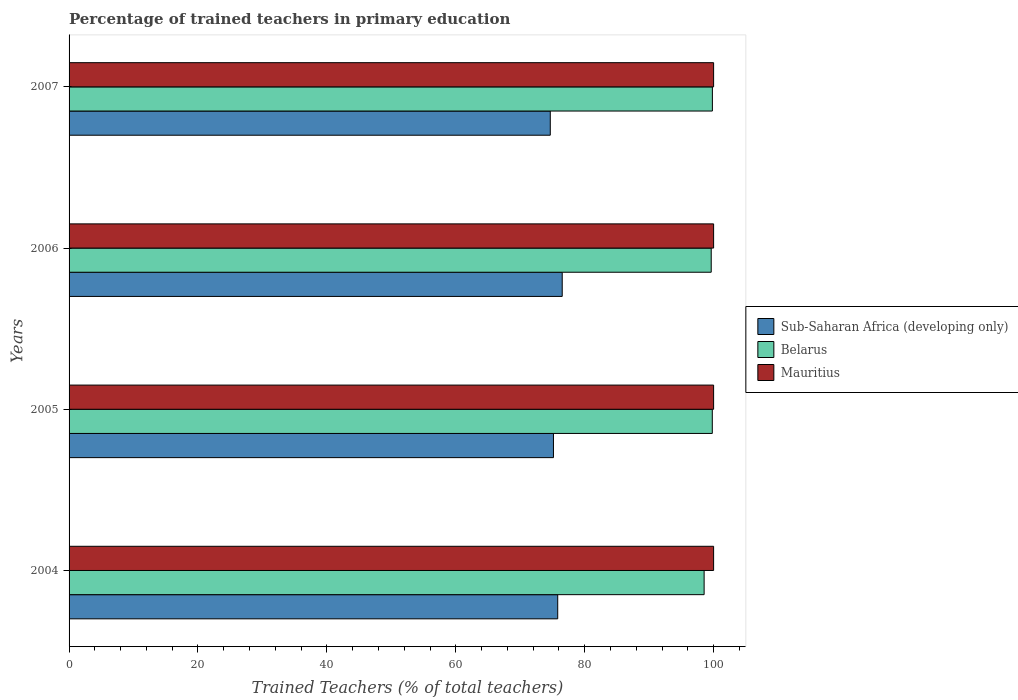How many different coloured bars are there?
Offer a very short reply. 3. How many groups of bars are there?
Your answer should be compact. 4. How many bars are there on the 3rd tick from the bottom?
Offer a terse response. 3. What is the label of the 4th group of bars from the top?
Keep it short and to the point. 2004. In how many cases, is the number of bars for a given year not equal to the number of legend labels?
Your answer should be compact. 0. What is the percentage of trained teachers in Mauritius in 2007?
Your answer should be very brief. 100. Across all years, what is the maximum percentage of trained teachers in Belarus?
Provide a succinct answer. 99.81. Across all years, what is the minimum percentage of trained teachers in Sub-Saharan Africa (developing only)?
Make the answer very short. 74.66. In which year was the percentage of trained teachers in Belarus minimum?
Ensure brevity in your answer.  2004. What is the total percentage of trained teachers in Sub-Saharan Africa (developing only) in the graph?
Your response must be concise. 302.14. What is the difference between the percentage of trained teachers in Mauritius in 2004 and that in 2005?
Provide a short and direct response. 0. What is the difference between the percentage of trained teachers in Mauritius in 2006 and the percentage of trained teachers in Belarus in 2007?
Make the answer very short. 0.19. In the year 2007, what is the difference between the percentage of trained teachers in Belarus and percentage of trained teachers in Sub-Saharan Africa (developing only)?
Offer a terse response. 25.15. In how many years, is the percentage of trained teachers in Belarus greater than 8 %?
Ensure brevity in your answer.  4. Is the difference between the percentage of trained teachers in Belarus in 2004 and 2005 greater than the difference between the percentage of trained teachers in Sub-Saharan Africa (developing only) in 2004 and 2005?
Provide a short and direct response. No. What is the difference between the highest and the second highest percentage of trained teachers in Belarus?
Your response must be concise. 0.01. What is the difference between the highest and the lowest percentage of trained teachers in Belarus?
Your answer should be compact. 1.28. In how many years, is the percentage of trained teachers in Belarus greater than the average percentage of trained teachers in Belarus taken over all years?
Offer a very short reply. 3. What does the 1st bar from the top in 2005 represents?
Ensure brevity in your answer.  Mauritius. What does the 3rd bar from the bottom in 2005 represents?
Make the answer very short. Mauritius. Is it the case that in every year, the sum of the percentage of trained teachers in Belarus and percentage of trained teachers in Mauritius is greater than the percentage of trained teachers in Sub-Saharan Africa (developing only)?
Offer a very short reply. Yes. How many bars are there?
Keep it short and to the point. 12. How many years are there in the graph?
Offer a terse response. 4. What is the difference between two consecutive major ticks on the X-axis?
Your answer should be very brief. 20. Does the graph contain any zero values?
Keep it short and to the point. No. Does the graph contain grids?
Your response must be concise. No. How many legend labels are there?
Ensure brevity in your answer.  3. What is the title of the graph?
Offer a very short reply. Percentage of trained teachers in primary education. Does "Solomon Islands" appear as one of the legend labels in the graph?
Offer a very short reply. No. What is the label or title of the X-axis?
Provide a succinct answer. Trained Teachers (% of total teachers). What is the Trained Teachers (% of total teachers) of Sub-Saharan Africa (developing only) in 2004?
Offer a terse response. 75.81. What is the Trained Teachers (% of total teachers) in Belarus in 2004?
Offer a very short reply. 98.53. What is the Trained Teachers (% of total teachers) of Mauritius in 2004?
Your response must be concise. 100. What is the Trained Teachers (% of total teachers) of Sub-Saharan Africa (developing only) in 2005?
Keep it short and to the point. 75.15. What is the Trained Teachers (% of total teachers) in Belarus in 2005?
Keep it short and to the point. 99.8. What is the Trained Teachers (% of total teachers) in Mauritius in 2005?
Keep it short and to the point. 100. What is the Trained Teachers (% of total teachers) of Sub-Saharan Africa (developing only) in 2006?
Your response must be concise. 76.51. What is the Trained Teachers (% of total teachers) in Belarus in 2006?
Your answer should be very brief. 99.63. What is the Trained Teachers (% of total teachers) of Sub-Saharan Africa (developing only) in 2007?
Provide a short and direct response. 74.66. What is the Trained Teachers (% of total teachers) in Belarus in 2007?
Offer a terse response. 99.81. Across all years, what is the maximum Trained Teachers (% of total teachers) of Sub-Saharan Africa (developing only)?
Ensure brevity in your answer.  76.51. Across all years, what is the maximum Trained Teachers (% of total teachers) of Belarus?
Keep it short and to the point. 99.81. Across all years, what is the minimum Trained Teachers (% of total teachers) in Sub-Saharan Africa (developing only)?
Keep it short and to the point. 74.66. Across all years, what is the minimum Trained Teachers (% of total teachers) of Belarus?
Keep it short and to the point. 98.53. Across all years, what is the minimum Trained Teachers (% of total teachers) in Mauritius?
Make the answer very short. 100. What is the total Trained Teachers (% of total teachers) of Sub-Saharan Africa (developing only) in the graph?
Offer a very short reply. 302.14. What is the total Trained Teachers (% of total teachers) of Belarus in the graph?
Ensure brevity in your answer.  397.76. What is the difference between the Trained Teachers (% of total teachers) of Sub-Saharan Africa (developing only) in 2004 and that in 2005?
Ensure brevity in your answer.  0.66. What is the difference between the Trained Teachers (% of total teachers) in Belarus in 2004 and that in 2005?
Your answer should be very brief. -1.27. What is the difference between the Trained Teachers (% of total teachers) of Sub-Saharan Africa (developing only) in 2004 and that in 2006?
Your answer should be compact. -0.7. What is the difference between the Trained Teachers (% of total teachers) of Belarus in 2004 and that in 2006?
Your answer should be very brief. -1.1. What is the difference between the Trained Teachers (% of total teachers) in Mauritius in 2004 and that in 2006?
Offer a terse response. 0. What is the difference between the Trained Teachers (% of total teachers) of Sub-Saharan Africa (developing only) in 2004 and that in 2007?
Give a very brief answer. 1.15. What is the difference between the Trained Teachers (% of total teachers) in Belarus in 2004 and that in 2007?
Provide a succinct answer. -1.28. What is the difference between the Trained Teachers (% of total teachers) in Sub-Saharan Africa (developing only) in 2005 and that in 2006?
Give a very brief answer. -1.36. What is the difference between the Trained Teachers (% of total teachers) of Belarus in 2005 and that in 2006?
Give a very brief answer. 0.17. What is the difference between the Trained Teachers (% of total teachers) of Mauritius in 2005 and that in 2006?
Provide a succinct answer. 0. What is the difference between the Trained Teachers (% of total teachers) of Sub-Saharan Africa (developing only) in 2005 and that in 2007?
Your answer should be very brief. 0.49. What is the difference between the Trained Teachers (% of total teachers) of Belarus in 2005 and that in 2007?
Provide a succinct answer. -0.01. What is the difference between the Trained Teachers (% of total teachers) of Mauritius in 2005 and that in 2007?
Ensure brevity in your answer.  0. What is the difference between the Trained Teachers (% of total teachers) in Sub-Saharan Africa (developing only) in 2006 and that in 2007?
Your answer should be very brief. 1.85. What is the difference between the Trained Teachers (% of total teachers) in Belarus in 2006 and that in 2007?
Keep it short and to the point. -0.18. What is the difference between the Trained Teachers (% of total teachers) of Sub-Saharan Africa (developing only) in 2004 and the Trained Teachers (% of total teachers) of Belarus in 2005?
Your response must be concise. -23.98. What is the difference between the Trained Teachers (% of total teachers) of Sub-Saharan Africa (developing only) in 2004 and the Trained Teachers (% of total teachers) of Mauritius in 2005?
Keep it short and to the point. -24.19. What is the difference between the Trained Teachers (% of total teachers) of Belarus in 2004 and the Trained Teachers (% of total teachers) of Mauritius in 2005?
Your answer should be very brief. -1.47. What is the difference between the Trained Teachers (% of total teachers) of Sub-Saharan Africa (developing only) in 2004 and the Trained Teachers (% of total teachers) of Belarus in 2006?
Your answer should be very brief. -23.82. What is the difference between the Trained Teachers (% of total teachers) of Sub-Saharan Africa (developing only) in 2004 and the Trained Teachers (% of total teachers) of Mauritius in 2006?
Your response must be concise. -24.19. What is the difference between the Trained Teachers (% of total teachers) in Belarus in 2004 and the Trained Teachers (% of total teachers) in Mauritius in 2006?
Make the answer very short. -1.47. What is the difference between the Trained Teachers (% of total teachers) of Sub-Saharan Africa (developing only) in 2004 and the Trained Teachers (% of total teachers) of Belarus in 2007?
Offer a very short reply. -24. What is the difference between the Trained Teachers (% of total teachers) of Sub-Saharan Africa (developing only) in 2004 and the Trained Teachers (% of total teachers) of Mauritius in 2007?
Make the answer very short. -24.19. What is the difference between the Trained Teachers (% of total teachers) of Belarus in 2004 and the Trained Teachers (% of total teachers) of Mauritius in 2007?
Your answer should be compact. -1.47. What is the difference between the Trained Teachers (% of total teachers) in Sub-Saharan Africa (developing only) in 2005 and the Trained Teachers (% of total teachers) in Belarus in 2006?
Your response must be concise. -24.48. What is the difference between the Trained Teachers (% of total teachers) of Sub-Saharan Africa (developing only) in 2005 and the Trained Teachers (% of total teachers) of Mauritius in 2006?
Keep it short and to the point. -24.85. What is the difference between the Trained Teachers (% of total teachers) of Belarus in 2005 and the Trained Teachers (% of total teachers) of Mauritius in 2006?
Make the answer very short. -0.2. What is the difference between the Trained Teachers (% of total teachers) of Sub-Saharan Africa (developing only) in 2005 and the Trained Teachers (% of total teachers) of Belarus in 2007?
Provide a short and direct response. -24.66. What is the difference between the Trained Teachers (% of total teachers) in Sub-Saharan Africa (developing only) in 2005 and the Trained Teachers (% of total teachers) in Mauritius in 2007?
Ensure brevity in your answer.  -24.85. What is the difference between the Trained Teachers (% of total teachers) of Belarus in 2005 and the Trained Teachers (% of total teachers) of Mauritius in 2007?
Offer a very short reply. -0.2. What is the difference between the Trained Teachers (% of total teachers) of Sub-Saharan Africa (developing only) in 2006 and the Trained Teachers (% of total teachers) of Belarus in 2007?
Offer a very short reply. -23.3. What is the difference between the Trained Teachers (% of total teachers) of Sub-Saharan Africa (developing only) in 2006 and the Trained Teachers (% of total teachers) of Mauritius in 2007?
Your answer should be very brief. -23.49. What is the difference between the Trained Teachers (% of total teachers) in Belarus in 2006 and the Trained Teachers (% of total teachers) in Mauritius in 2007?
Give a very brief answer. -0.37. What is the average Trained Teachers (% of total teachers) of Sub-Saharan Africa (developing only) per year?
Offer a terse response. 75.53. What is the average Trained Teachers (% of total teachers) in Belarus per year?
Your response must be concise. 99.44. In the year 2004, what is the difference between the Trained Teachers (% of total teachers) in Sub-Saharan Africa (developing only) and Trained Teachers (% of total teachers) in Belarus?
Your answer should be very brief. -22.71. In the year 2004, what is the difference between the Trained Teachers (% of total teachers) of Sub-Saharan Africa (developing only) and Trained Teachers (% of total teachers) of Mauritius?
Your answer should be compact. -24.19. In the year 2004, what is the difference between the Trained Teachers (% of total teachers) in Belarus and Trained Teachers (% of total teachers) in Mauritius?
Offer a terse response. -1.47. In the year 2005, what is the difference between the Trained Teachers (% of total teachers) of Sub-Saharan Africa (developing only) and Trained Teachers (% of total teachers) of Belarus?
Keep it short and to the point. -24.65. In the year 2005, what is the difference between the Trained Teachers (% of total teachers) in Sub-Saharan Africa (developing only) and Trained Teachers (% of total teachers) in Mauritius?
Keep it short and to the point. -24.85. In the year 2005, what is the difference between the Trained Teachers (% of total teachers) in Belarus and Trained Teachers (% of total teachers) in Mauritius?
Keep it short and to the point. -0.2. In the year 2006, what is the difference between the Trained Teachers (% of total teachers) of Sub-Saharan Africa (developing only) and Trained Teachers (% of total teachers) of Belarus?
Give a very brief answer. -23.12. In the year 2006, what is the difference between the Trained Teachers (% of total teachers) of Sub-Saharan Africa (developing only) and Trained Teachers (% of total teachers) of Mauritius?
Give a very brief answer. -23.49. In the year 2006, what is the difference between the Trained Teachers (% of total teachers) of Belarus and Trained Teachers (% of total teachers) of Mauritius?
Keep it short and to the point. -0.37. In the year 2007, what is the difference between the Trained Teachers (% of total teachers) in Sub-Saharan Africa (developing only) and Trained Teachers (% of total teachers) in Belarus?
Offer a terse response. -25.15. In the year 2007, what is the difference between the Trained Teachers (% of total teachers) of Sub-Saharan Africa (developing only) and Trained Teachers (% of total teachers) of Mauritius?
Your answer should be very brief. -25.34. In the year 2007, what is the difference between the Trained Teachers (% of total teachers) in Belarus and Trained Teachers (% of total teachers) in Mauritius?
Keep it short and to the point. -0.19. What is the ratio of the Trained Teachers (% of total teachers) of Sub-Saharan Africa (developing only) in 2004 to that in 2005?
Keep it short and to the point. 1.01. What is the ratio of the Trained Teachers (% of total teachers) in Belarus in 2004 to that in 2005?
Give a very brief answer. 0.99. What is the ratio of the Trained Teachers (% of total teachers) in Sub-Saharan Africa (developing only) in 2004 to that in 2006?
Keep it short and to the point. 0.99. What is the ratio of the Trained Teachers (% of total teachers) in Belarus in 2004 to that in 2006?
Your answer should be compact. 0.99. What is the ratio of the Trained Teachers (% of total teachers) of Mauritius in 2004 to that in 2006?
Keep it short and to the point. 1. What is the ratio of the Trained Teachers (% of total teachers) of Sub-Saharan Africa (developing only) in 2004 to that in 2007?
Offer a very short reply. 1.02. What is the ratio of the Trained Teachers (% of total teachers) in Belarus in 2004 to that in 2007?
Make the answer very short. 0.99. What is the ratio of the Trained Teachers (% of total teachers) of Mauritius in 2004 to that in 2007?
Your answer should be compact. 1. What is the ratio of the Trained Teachers (% of total teachers) in Sub-Saharan Africa (developing only) in 2005 to that in 2006?
Your answer should be very brief. 0.98. What is the ratio of the Trained Teachers (% of total teachers) of Belarus in 2005 to that in 2006?
Provide a short and direct response. 1. What is the ratio of the Trained Teachers (% of total teachers) of Mauritius in 2005 to that in 2006?
Offer a terse response. 1. What is the ratio of the Trained Teachers (% of total teachers) of Sub-Saharan Africa (developing only) in 2005 to that in 2007?
Offer a very short reply. 1.01. What is the ratio of the Trained Teachers (% of total teachers) in Belarus in 2005 to that in 2007?
Ensure brevity in your answer.  1. What is the ratio of the Trained Teachers (% of total teachers) in Sub-Saharan Africa (developing only) in 2006 to that in 2007?
Your answer should be compact. 1.02. What is the ratio of the Trained Teachers (% of total teachers) in Belarus in 2006 to that in 2007?
Your answer should be very brief. 1. What is the ratio of the Trained Teachers (% of total teachers) of Mauritius in 2006 to that in 2007?
Provide a succinct answer. 1. What is the difference between the highest and the second highest Trained Teachers (% of total teachers) of Sub-Saharan Africa (developing only)?
Make the answer very short. 0.7. What is the difference between the highest and the second highest Trained Teachers (% of total teachers) in Belarus?
Offer a terse response. 0.01. What is the difference between the highest and the lowest Trained Teachers (% of total teachers) of Sub-Saharan Africa (developing only)?
Give a very brief answer. 1.85. What is the difference between the highest and the lowest Trained Teachers (% of total teachers) in Belarus?
Offer a terse response. 1.28. What is the difference between the highest and the lowest Trained Teachers (% of total teachers) of Mauritius?
Make the answer very short. 0. 